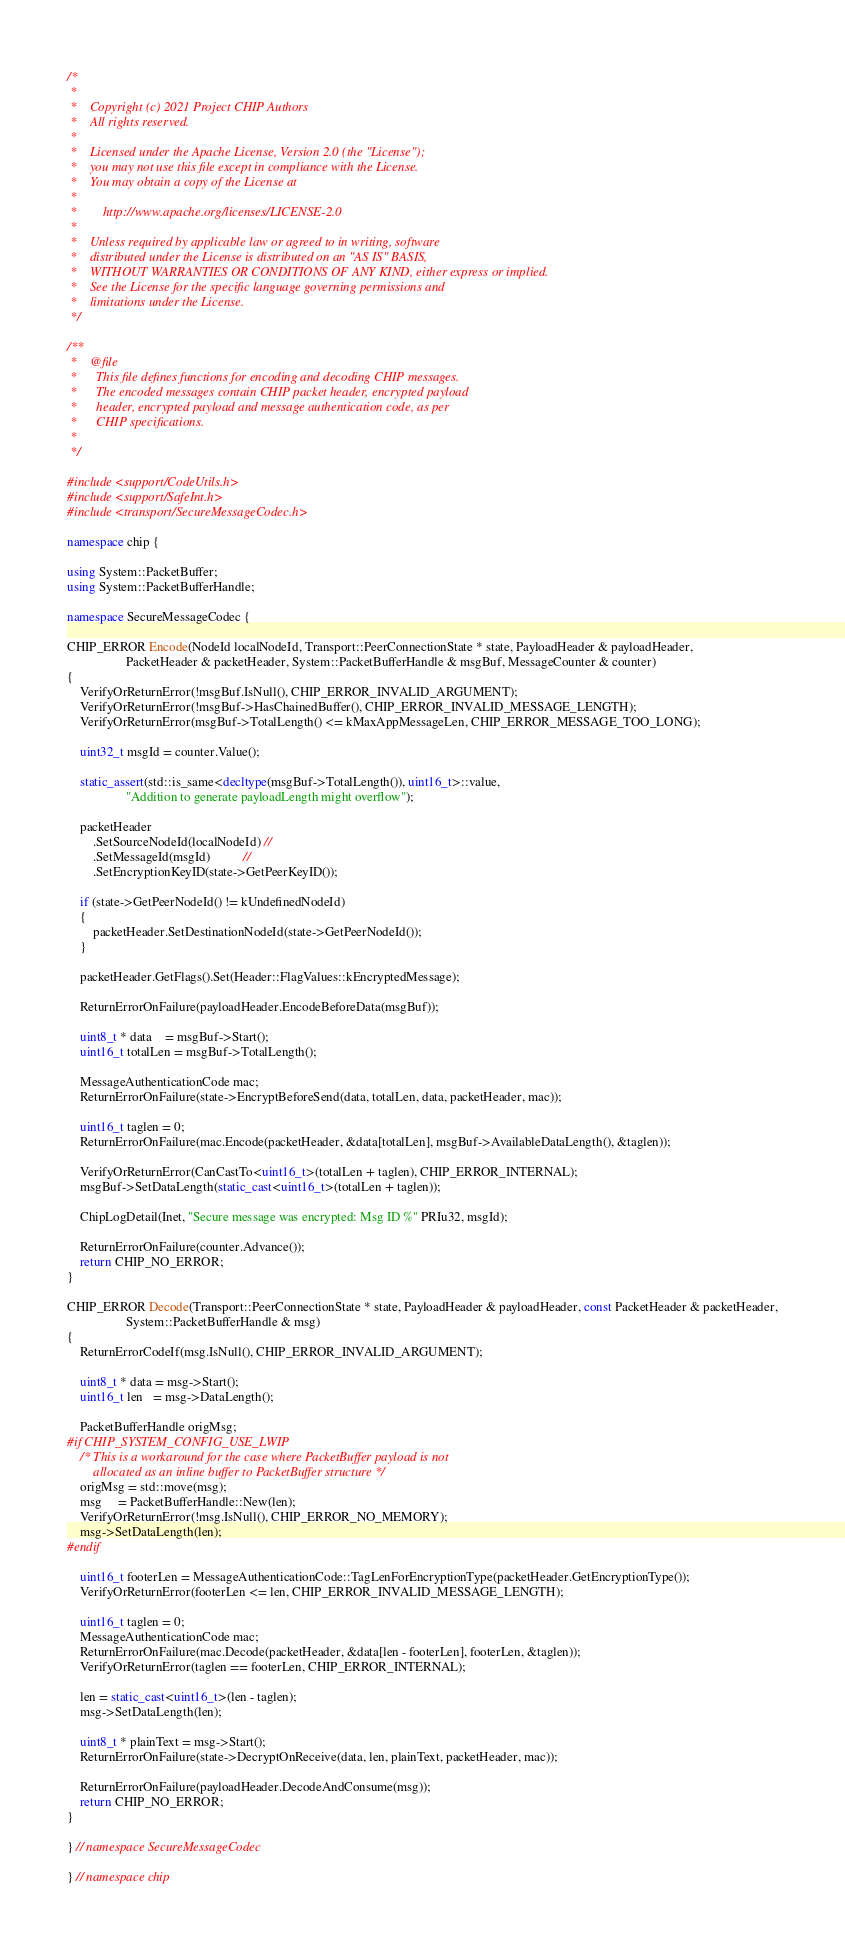Convert code to text. <code><loc_0><loc_0><loc_500><loc_500><_C++_>/*
 *
 *    Copyright (c) 2021 Project CHIP Authors
 *    All rights reserved.
 *
 *    Licensed under the Apache License, Version 2.0 (the "License");
 *    you may not use this file except in compliance with the License.
 *    You may obtain a copy of the License at
 *
 *        http://www.apache.org/licenses/LICENSE-2.0
 *
 *    Unless required by applicable law or agreed to in writing, software
 *    distributed under the License is distributed on an "AS IS" BASIS,
 *    WITHOUT WARRANTIES OR CONDITIONS OF ANY KIND, either express or implied.
 *    See the License for the specific language governing permissions and
 *    limitations under the License.
 */

/**
 *    @file
 *      This file defines functions for encoding and decoding CHIP messages.
 *      The encoded messages contain CHIP packet header, encrypted payload
 *      header, encrypted payload and message authentication code, as per
 *      CHIP specifications.
 *
 */

#include <support/CodeUtils.h>
#include <support/SafeInt.h>
#include <transport/SecureMessageCodec.h>

namespace chip {

using System::PacketBuffer;
using System::PacketBufferHandle;

namespace SecureMessageCodec {

CHIP_ERROR Encode(NodeId localNodeId, Transport::PeerConnectionState * state, PayloadHeader & payloadHeader,
                  PacketHeader & packetHeader, System::PacketBufferHandle & msgBuf, MessageCounter & counter)
{
    VerifyOrReturnError(!msgBuf.IsNull(), CHIP_ERROR_INVALID_ARGUMENT);
    VerifyOrReturnError(!msgBuf->HasChainedBuffer(), CHIP_ERROR_INVALID_MESSAGE_LENGTH);
    VerifyOrReturnError(msgBuf->TotalLength() <= kMaxAppMessageLen, CHIP_ERROR_MESSAGE_TOO_LONG);

    uint32_t msgId = counter.Value();

    static_assert(std::is_same<decltype(msgBuf->TotalLength()), uint16_t>::value,
                  "Addition to generate payloadLength might overflow");

    packetHeader
        .SetSourceNodeId(localNodeId) //
        .SetMessageId(msgId)          //
        .SetEncryptionKeyID(state->GetPeerKeyID());

    if (state->GetPeerNodeId() != kUndefinedNodeId)
    {
        packetHeader.SetDestinationNodeId(state->GetPeerNodeId());
    }

    packetHeader.GetFlags().Set(Header::FlagValues::kEncryptedMessage);

    ReturnErrorOnFailure(payloadHeader.EncodeBeforeData(msgBuf));

    uint8_t * data    = msgBuf->Start();
    uint16_t totalLen = msgBuf->TotalLength();

    MessageAuthenticationCode mac;
    ReturnErrorOnFailure(state->EncryptBeforeSend(data, totalLen, data, packetHeader, mac));

    uint16_t taglen = 0;
    ReturnErrorOnFailure(mac.Encode(packetHeader, &data[totalLen], msgBuf->AvailableDataLength(), &taglen));

    VerifyOrReturnError(CanCastTo<uint16_t>(totalLen + taglen), CHIP_ERROR_INTERNAL);
    msgBuf->SetDataLength(static_cast<uint16_t>(totalLen + taglen));

    ChipLogDetail(Inet, "Secure message was encrypted: Msg ID %" PRIu32, msgId);

    ReturnErrorOnFailure(counter.Advance());
    return CHIP_NO_ERROR;
}

CHIP_ERROR Decode(Transport::PeerConnectionState * state, PayloadHeader & payloadHeader, const PacketHeader & packetHeader,
                  System::PacketBufferHandle & msg)
{
    ReturnErrorCodeIf(msg.IsNull(), CHIP_ERROR_INVALID_ARGUMENT);

    uint8_t * data = msg->Start();
    uint16_t len   = msg->DataLength();

    PacketBufferHandle origMsg;
#if CHIP_SYSTEM_CONFIG_USE_LWIP
    /* This is a workaround for the case where PacketBuffer payload is not
        allocated as an inline buffer to PacketBuffer structure */
    origMsg = std::move(msg);
    msg     = PacketBufferHandle::New(len);
    VerifyOrReturnError(!msg.IsNull(), CHIP_ERROR_NO_MEMORY);
    msg->SetDataLength(len);
#endif

    uint16_t footerLen = MessageAuthenticationCode::TagLenForEncryptionType(packetHeader.GetEncryptionType());
    VerifyOrReturnError(footerLen <= len, CHIP_ERROR_INVALID_MESSAGE_LENGTH);

    uint16_t taglen = 0;
    MessageAuthenticationCode mac;
    ReturnErrorOnFailure(mac.Decode(packetHeader, &data[len - footerLen], footerLen, &taglen));
    VerifyOrReturnError(taglen == footerLen, CHIP_ERROR_INTERNAL);

    len = static_cast<uint16_t>(len - taglen);
    msg->SetDataLength(len);

    uint8_t * plainText = msg->Start();
    ReturnErrorOnFailure(state->DecryptOnReceive(data, len, plainText, packetHeader, mac));

    ReturnErrorOnFailure(payloadHeader.DecodeAndConsume(msg));
    return CHIP_NO_ERROR;
}

} // namespace SecureMessageCodec

} // namespace chip
</code> 